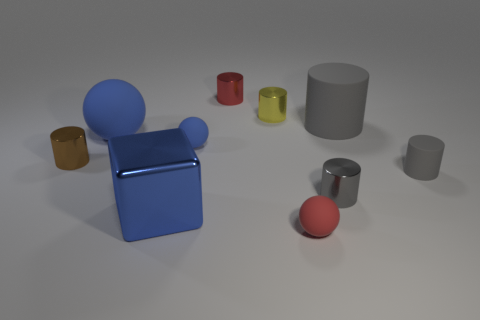Subtract all gray cylinders. How many were subtracted if there are1gray cylinders left? 2 Subtract all gray cubes. How many gray cylinders are left? 3 Subtract 3 cylinders. How many cylinders are left? 3 Subtract all small yellow cylinders. How many cylinders are left? 5 Subtract all brown cylinders. How many cylinders are left? 5 Subtract all brown cylinders. Subtract all red balls. How many cylinders are left? 5 Subtract all cylinders. How many objects are left? 4 Subtract all gray cylinders. Subtract all gray matte objects. How many objects are left? 5 Add 8 tiny rubber cylinders. How many tiny rubber cylinders are left? 9 Add 5 small yellow metallic things. How many small yellow metallic things exist? 6 